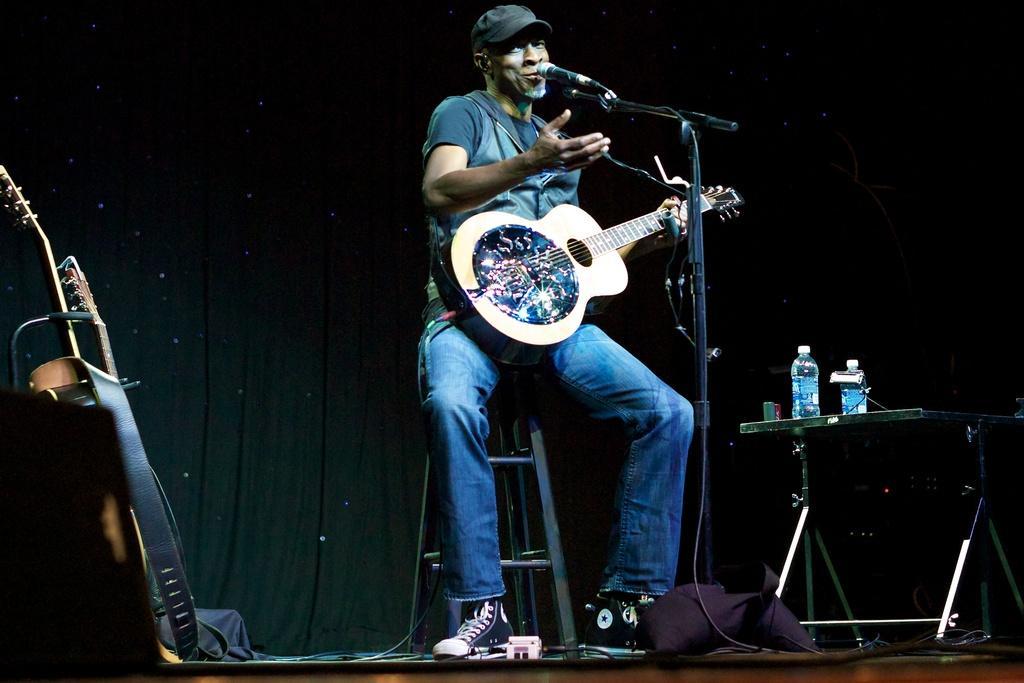Please provide a concise description of this image. This is the picture on a stage, the man is sitting on the chair and the man is singing a song. This is a microphone and this is a microphone stand the man holding the guitar. Beside the man there is a table on there is two water bottles and the beside the man there is other guitar. Background of the man there is a black color curtain. 